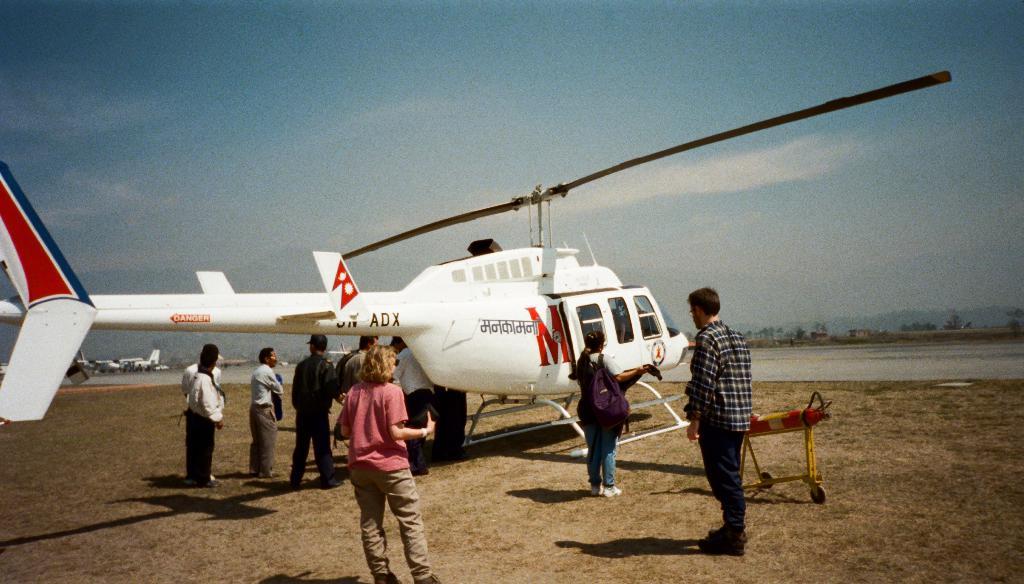What letters are visible on the tail of the helicopter?
Offer a very short reply. Adx. 